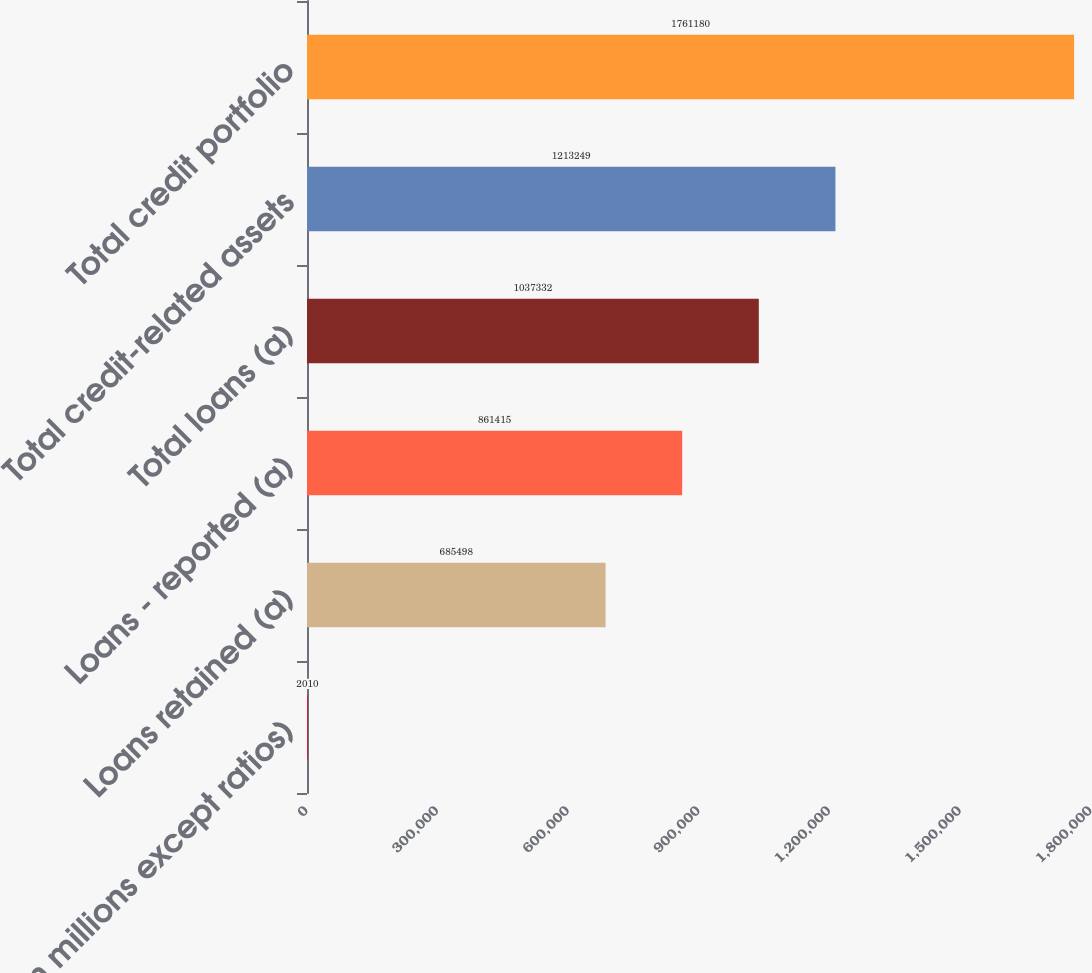Convert chart to OTSL. <chart><loc_0><loc_0><loc_500><loc_500><bar_chart><fcel>(in millions except ratios)<fcel>Loans retained (a)<fcel>Loans - reported (a)<fcel>Total loans (a)<fcel>Total credit-related assets<fcel>Total credit portfolio<nl><fcel>2010<fcel>685498<fcel>861415<fcel>1.03733e+06<fcel>1.21325e+06<fcel>1.76118e+06<nl></chart> 